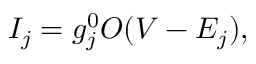Convert formula to latex. <formula><loc_0><loc_0><loc_500><loc_500>I _ { j } = g _ { j } ^ { 0 } O ( V - E _ { j } ) ,</formula> 